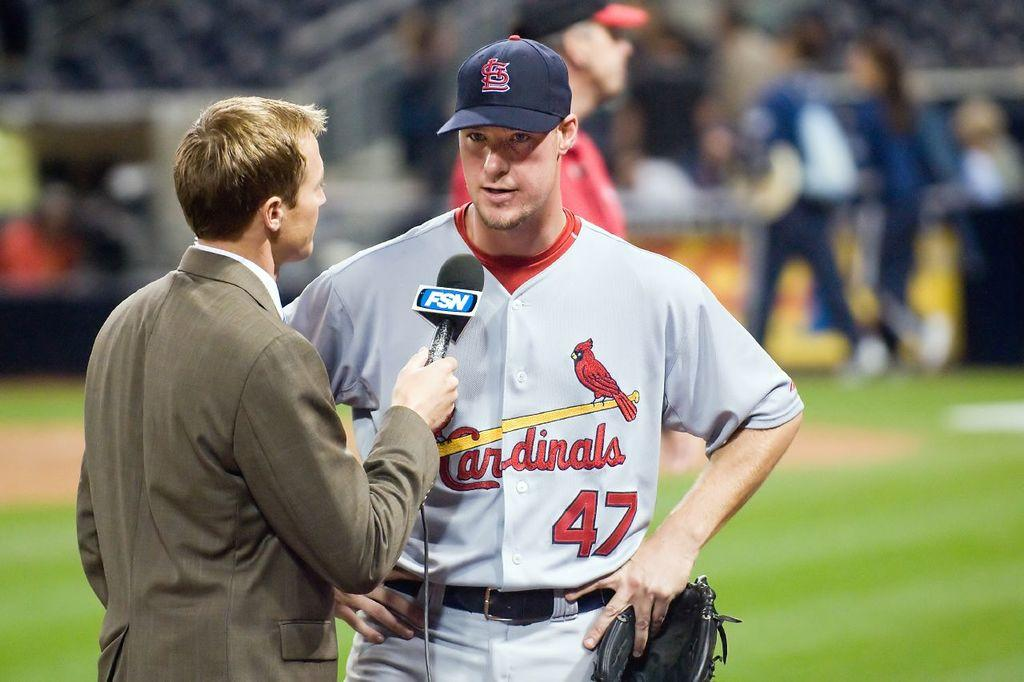Provide a one-sentence caption for the provided image. a Cardinals 47 baseball player interviewed on the field. 